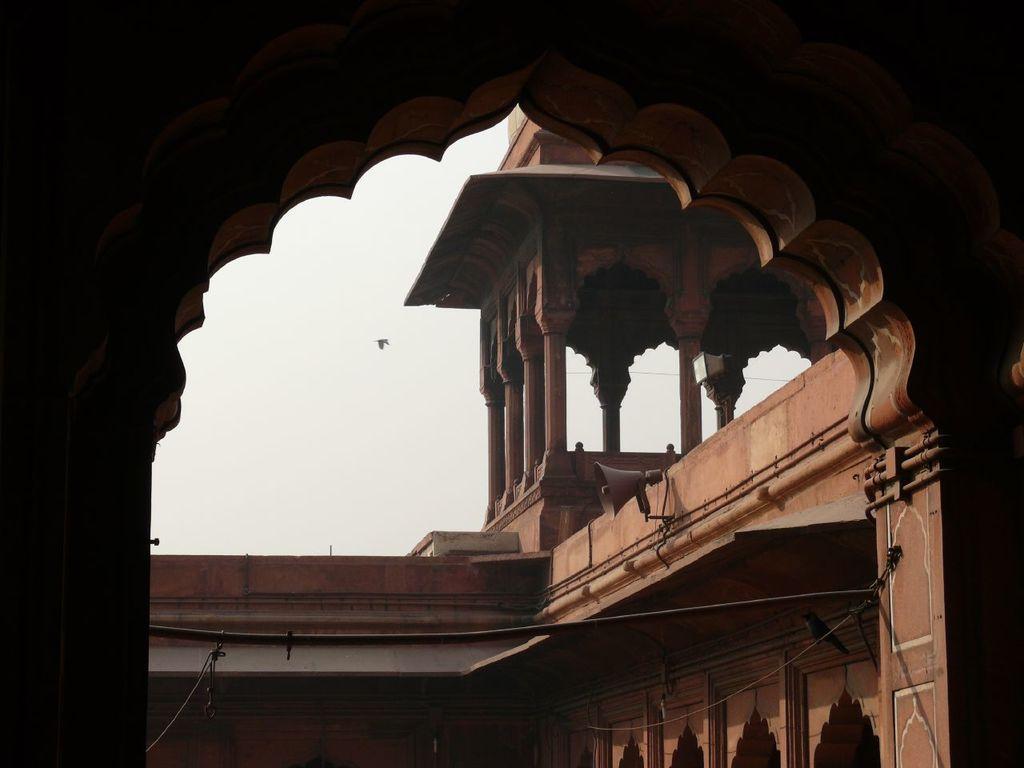Can you describe this image briefly? In this image in the foreground there is one fort and in the center there is sky, on the right side there is one speaker. 